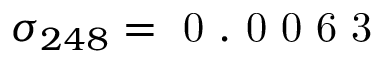<formula> <loc_0><loc_0><loc_500><loc_500>\sigma _ { 2 4 8 } = 0 . 0 0 6 3</formula> 